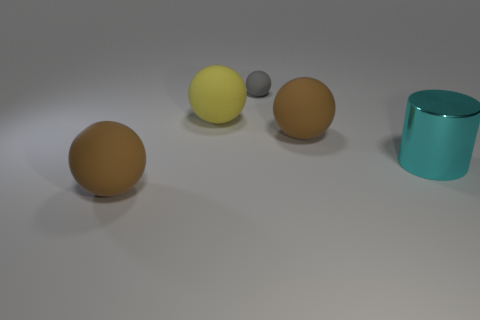What number of other things are made of the same material as the large yellow thing?
Your answer should be very brief. 3. How many cyan metallic objects are the same size as the yellow sphere?
Give a very brief answer. 1. How big is the brown sphere that is in front of the brown object on the right side of the big yellow sphere?
Your answer should be compact. Large. Do the large brown object that is behind the cyan metal thing and the big brown object left of the gray matte object have the same shape?
Your answer should be very brief. Yes. There is a big thing that is right of the large yellow ball and behind the cylinder; what is its color?
Provide a short and direct response. Brown. Is there another cylinder of the same color as the large cylinder?
Your answer should be very brief. No. There is a matte thing on the left side of the yellow matte ball; what color is it?
Make the answer very short. Brown. There is a large rubber object that is on the right side of the tiny gray sphere; is there a cyan cylinder that is on the left side of it?
Make the answer very short. No. Do the small sphere and the metal object on the right side of the gray thing have the same color?
Offer a terse response. No. Is there a large cyan cylinder that has the same material as the large cyan thing?
Offer a terse response. No. 